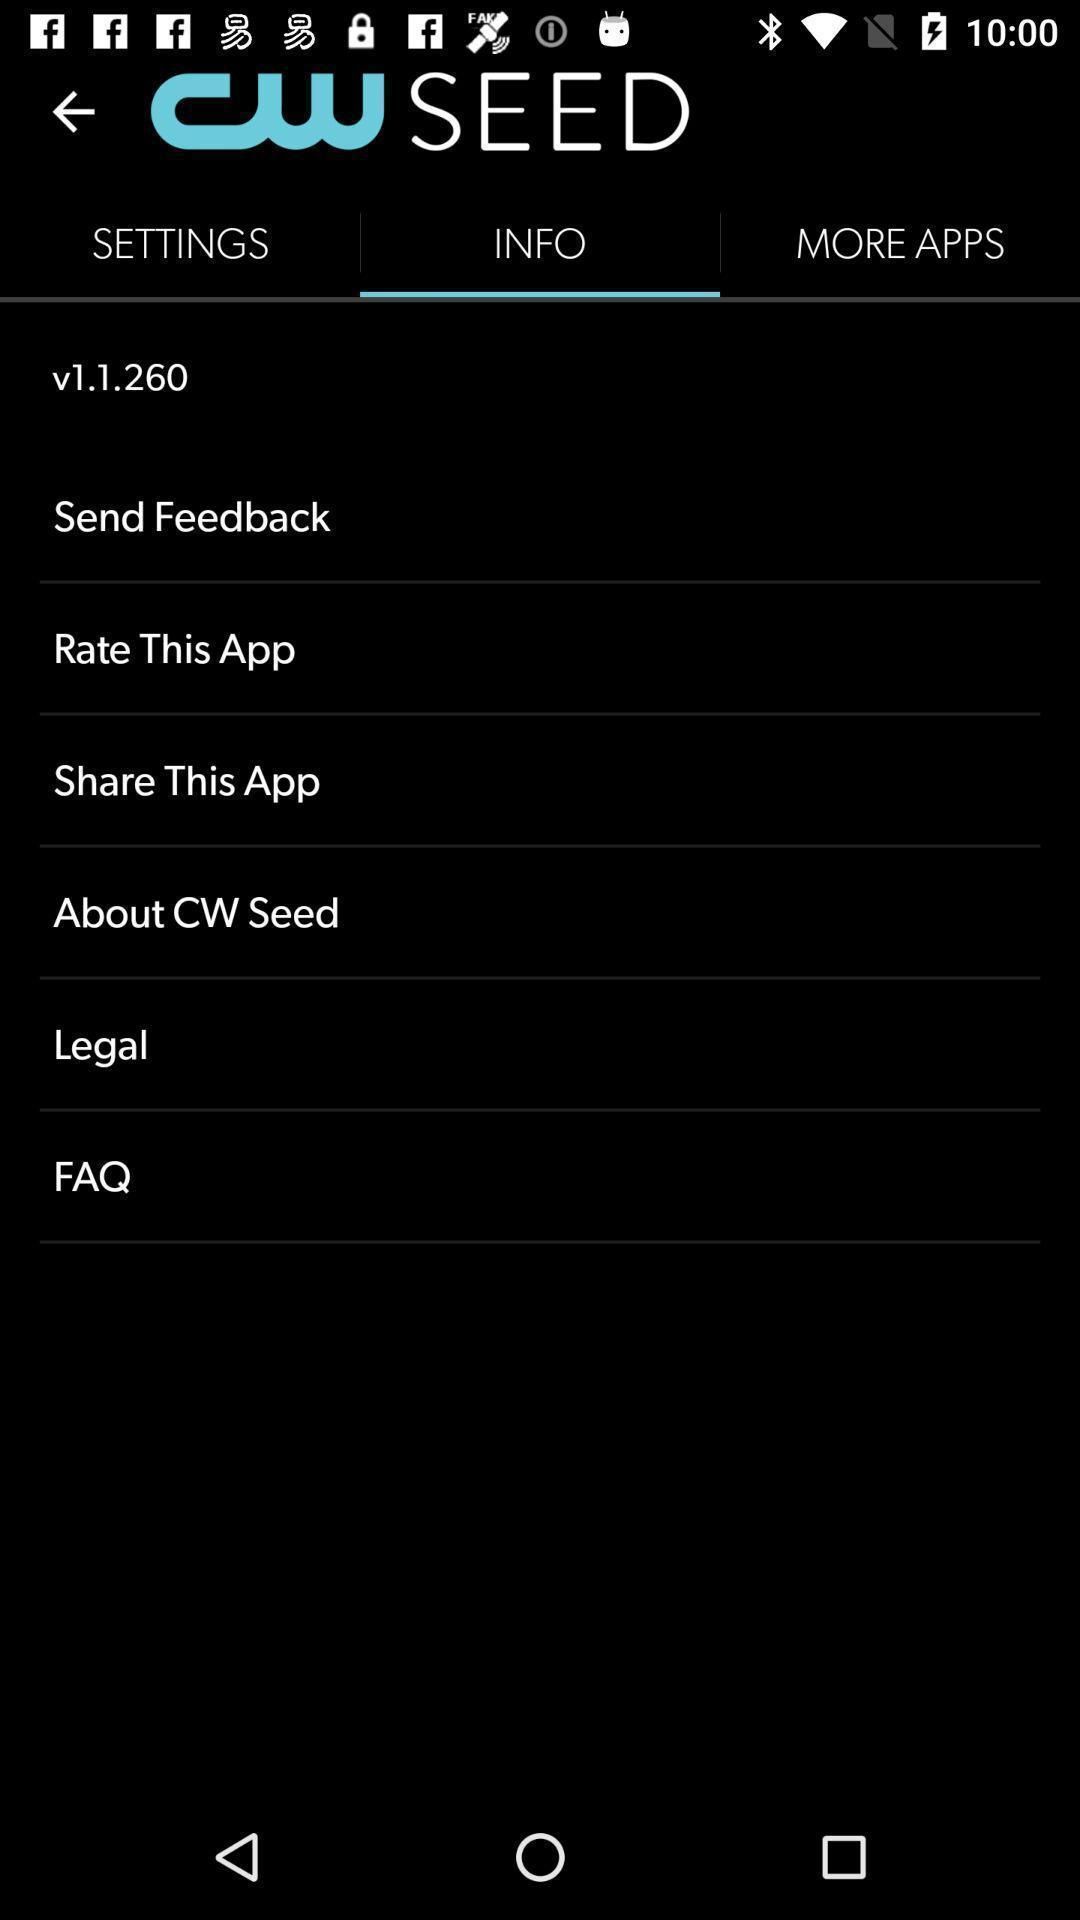Please provide a description for this image. Page displaying the more options of social app. 